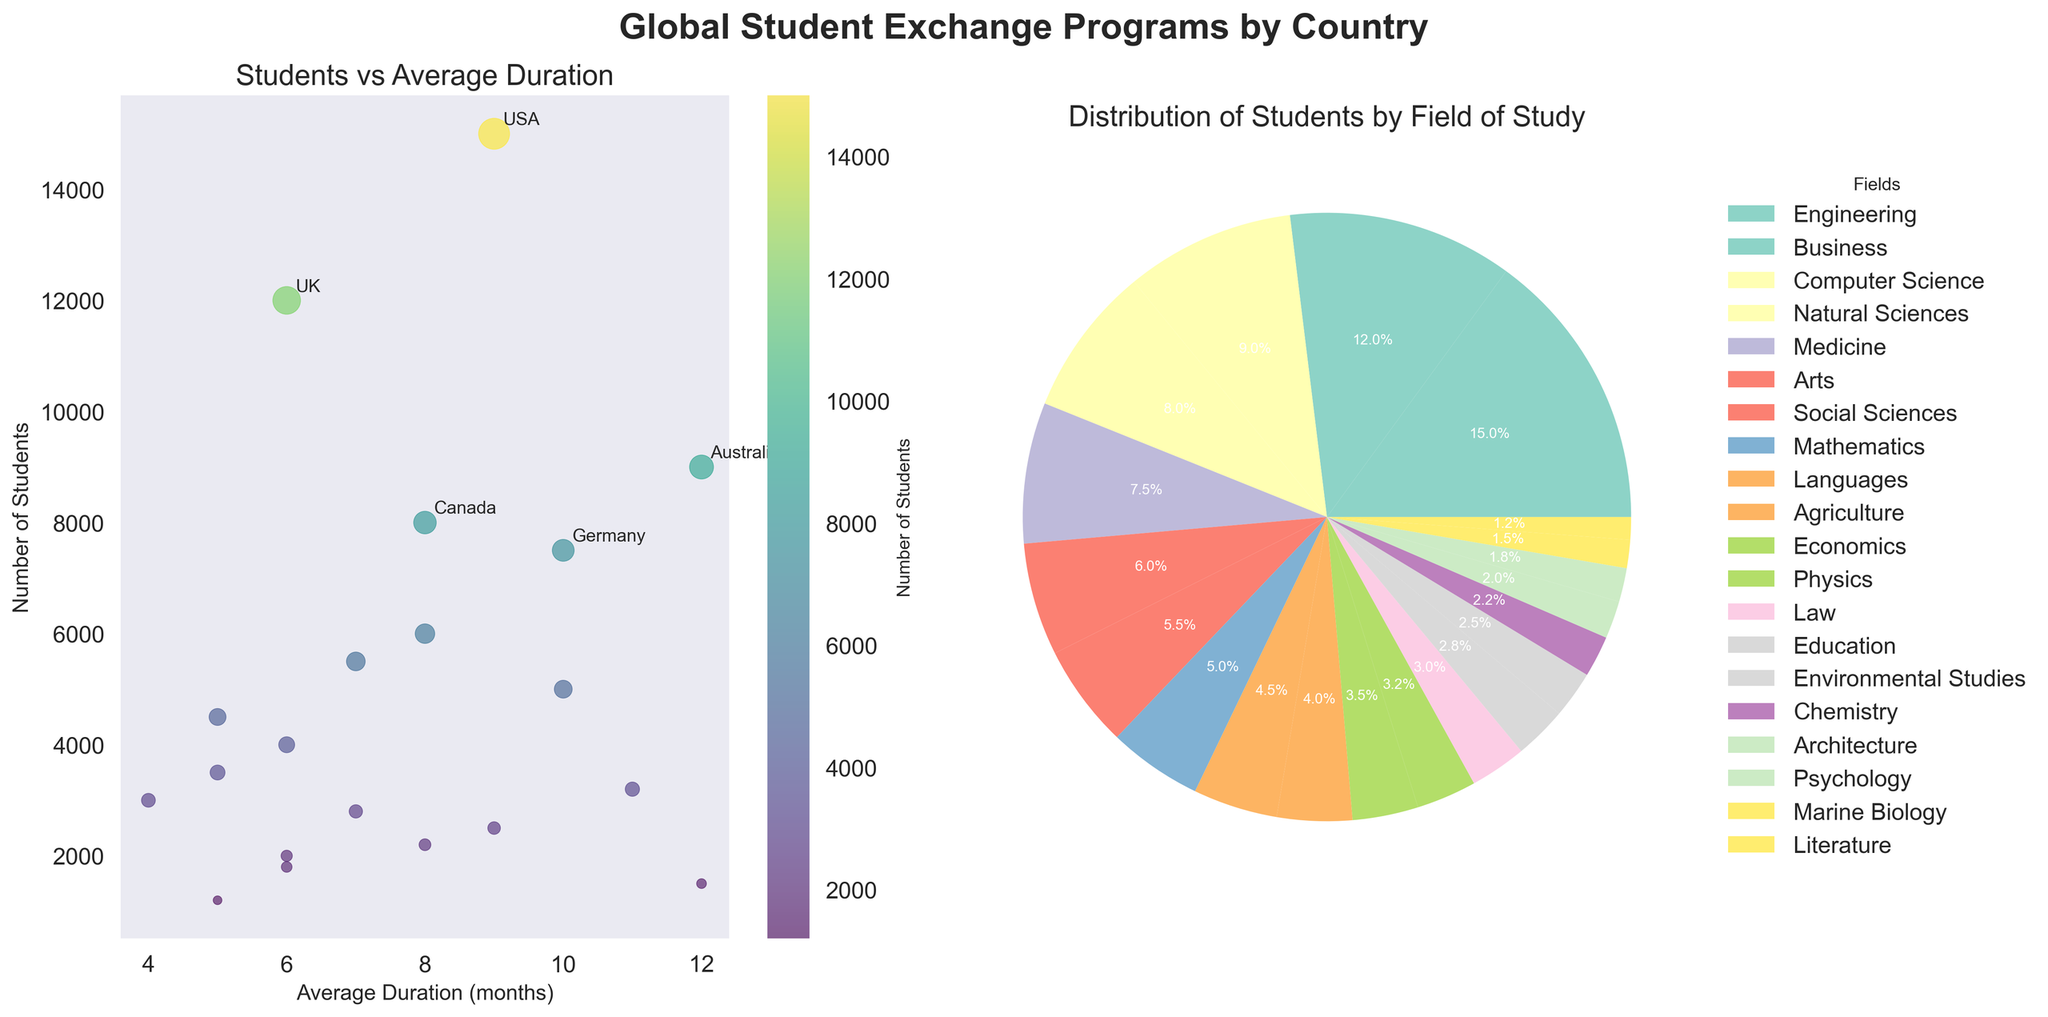What is the title of the left plot? The title is displayed at the top of the left plot. It reads "Students vs Average Duration," indicating what is being depicted on the X and Y axes.
Answer: Students vs Average Duration How many students are studying Engineering in the USA? The bubble chart on the left shows the number of students (size of the bubble) and annotates the top 5 countries. For the USA, the annotation overlaps with its corresponding bubble showing it has 15,000 students.
Answer: 15,000 Which country has the highest number of students in exchange programs? The left bubble chart indicates the number of students, and the largest bubble size with annotation shows that the USA has the highest, which is further confirmed by its annotation value of 15,000 students.
Answer: USA What is the average duration of exchange programs for countries with the top 5 highest number of students? The top 5 countries by the number of students are USA (9), UK (6), Australia (12), Germany (10), and Japan (8). The average duration is calculated by averaging these values: (9 + 6 + 12 + 10 + 8) / 5 = 9 months.
Answer: 9 months Which field of study has the largest share of students in exchange programs? The pie chart on the right shows the distribution of students by field of study. The largest wedge corresponds to "Engineering," as indicated by its relative size compared to others.
Answer: Engineering How many countries' average program duration is over 10 months? From the left plot, we can observe the X-axis representing the average program duration. There are four countries with an average duration over 10 months, corresponding to Australia, New Zealand, Russia, and Germany.
Answer: 4 What is the difference in the number of students between the biggest and smallest fields of study? Referencing the pie chart, the largest field (Engineering) has 15,000 students, and the smallest field (Literature) has 1,200 students. The difference is 15,000 - 1,200 = 13,800 students.
Answer: 13,800 Which country has the shortest average duration for their exchange programs? The bubble chart's X-axis shows the average duration, and the smallest value belongs to Singapore with an average duration of 4 months, as indicated by its position.
Answer: Singapore Which countries are labeled in the left plot, and why? The left plot has annotations for the top 5 countries by the number of students, which are USA, UK, Australia, Germany, and Japan. These countries are highlighted because they have the highest student counts among all included countries.
Answer: USA, UK, Australia, Germany, Japan What percentage of students are studying Business fields? The pie chart on the right gives the exact percentage distribution for each field of study. Based on the chart, Business accounts for 13.9% of total students.
Answer: 13.9% 